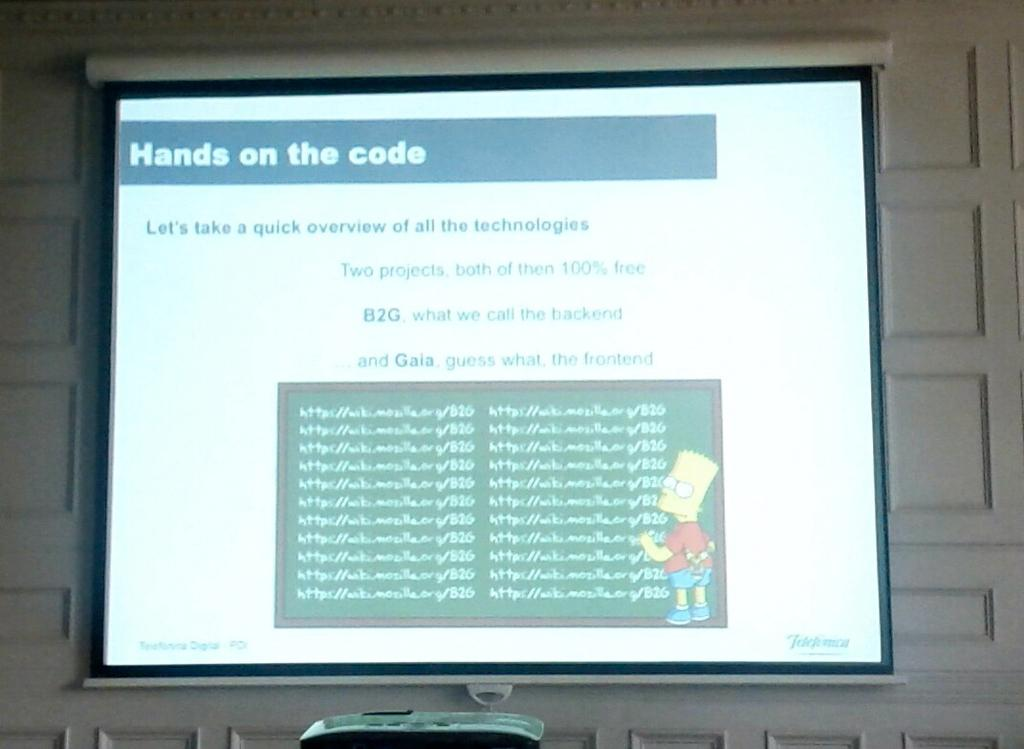<image>
Summarize the visual content of the image. A computer monitor, where the screen indicates that the work being done is titled Hands on the Code. 